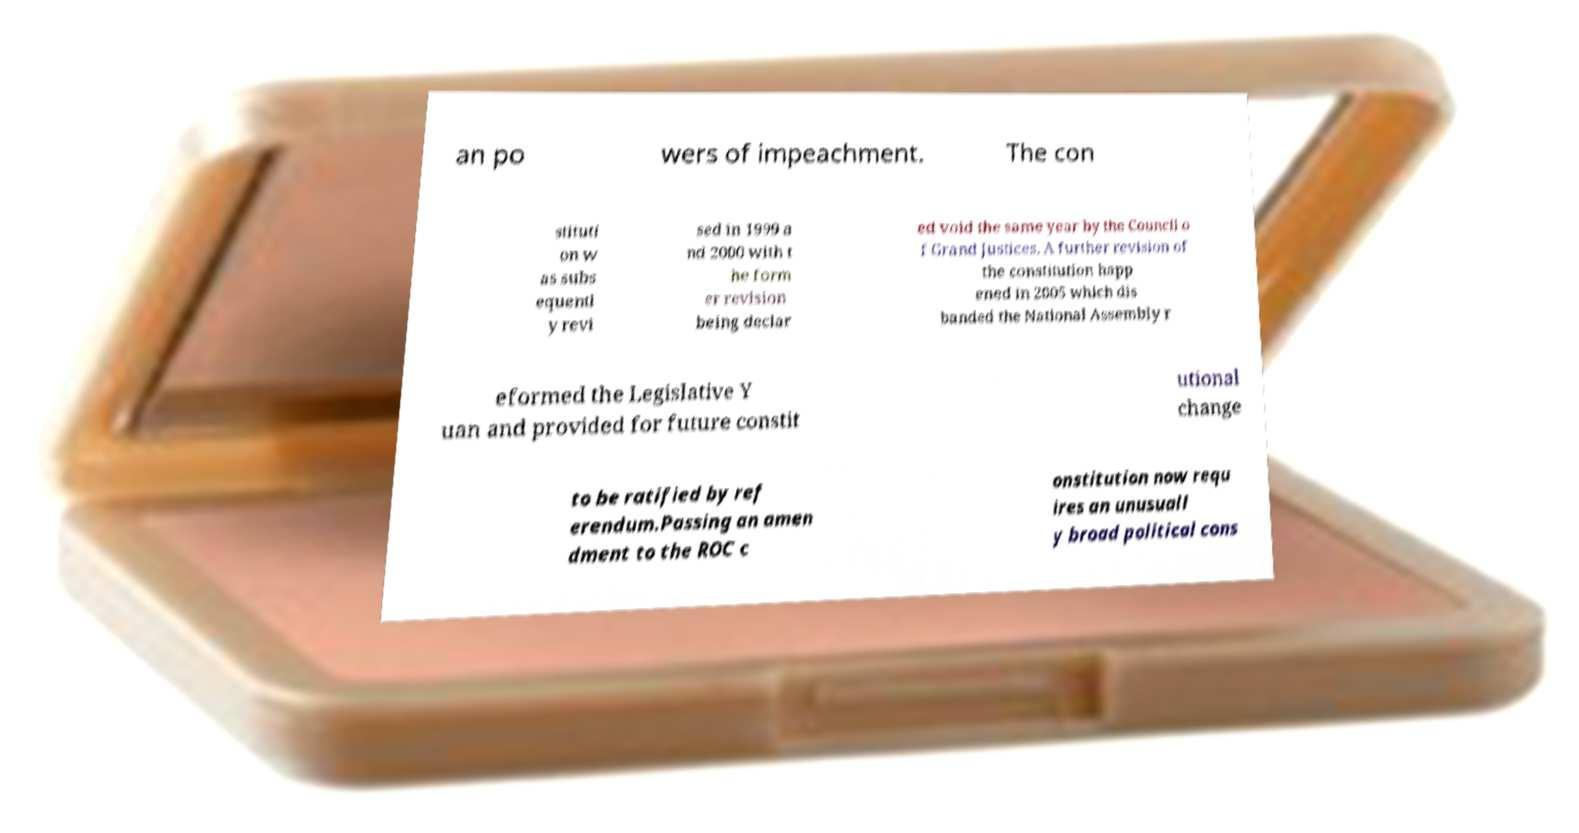Can you read and provide the text displayed in the image?This photo seems to have some interesting text. Can you extract and type it out for me? an po wers of impeachment. The con stituti on w as subs equentl y revi sed in 1999 a nd 2000 with t he form er revision being declar ed void the same year by the Council o f Grand Justices. A further revision of the constitution happ ened in 2005 which dis banded the National Assembly r eformed the Legislative Y uan and provided for future constit utional change to be ratified by ref erendum.Passing an amen dment to the ROC c onstitution now requ ires an unusuall y broad political cons 